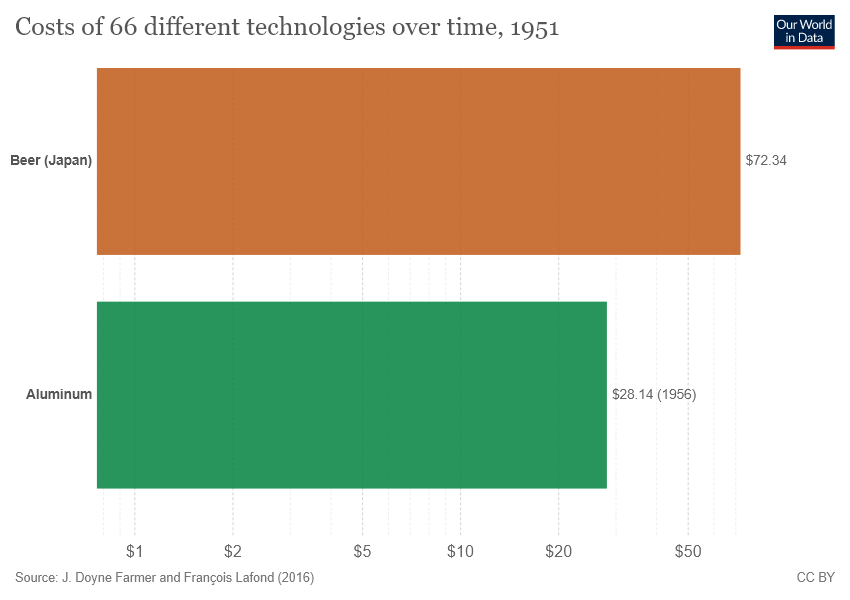List a handful of essential elements in this visual. The value of the green bar is 28.14. The sum of orange and green bars is 100.48. 